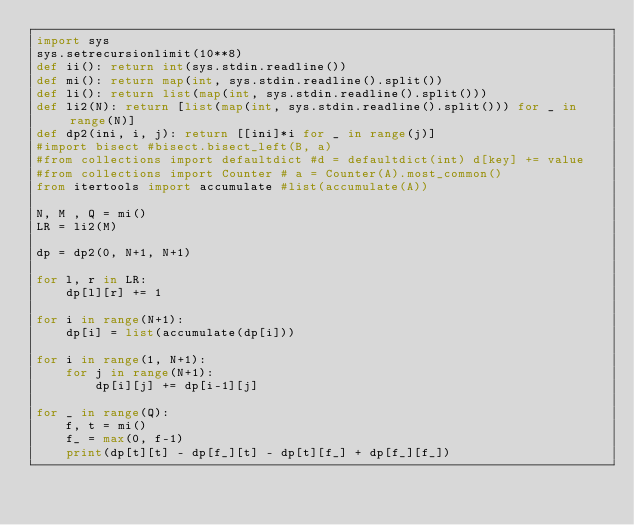Convert code to text. <code><loc_0><loc_0><loc_500><loc_500><_Python_>import sys
sys.setrecursionlimit(10**8)
def ii(): return int(sys.stdin.readline())
def mi(): return map(int, sys.stdin.readline().split())
def li(): return list(map(int, sys.stdin.readline().split()))
def li2(N): return [list(map(int, sys.stdin.readline().split())) for _ in range(N)]
def dp2(ini, i, j): return [[ini]*i for _ in range(j)]
#import bisect #bisect.bisect_left(B, a)
#from collections import defaultdict #d = defaultdict(int) d[key] += value
#from collections import Counter # a = Counter(A).most_common()
from itertools import accumulate #list(accumulate(A))

N, M , Q = mi()
LR = li2(M)

dp = dp2(0, N+1, N+1)

for l, r in LR:
    dp[l][r] += 1

for i in range(N+1):
    dp[i] = list(accumulate(dp[i]))

for i in range(1, N+1):
    for j in range(N+1):
        dp[i][j] += dp[i-1][j]

for _ in range(Q):
    f, t = mi()
    f_ = max(0, f-1)
    print(dp[t][t] - dp[f_][t] - dp[t][f_] + dp[f_][f_])</code> 